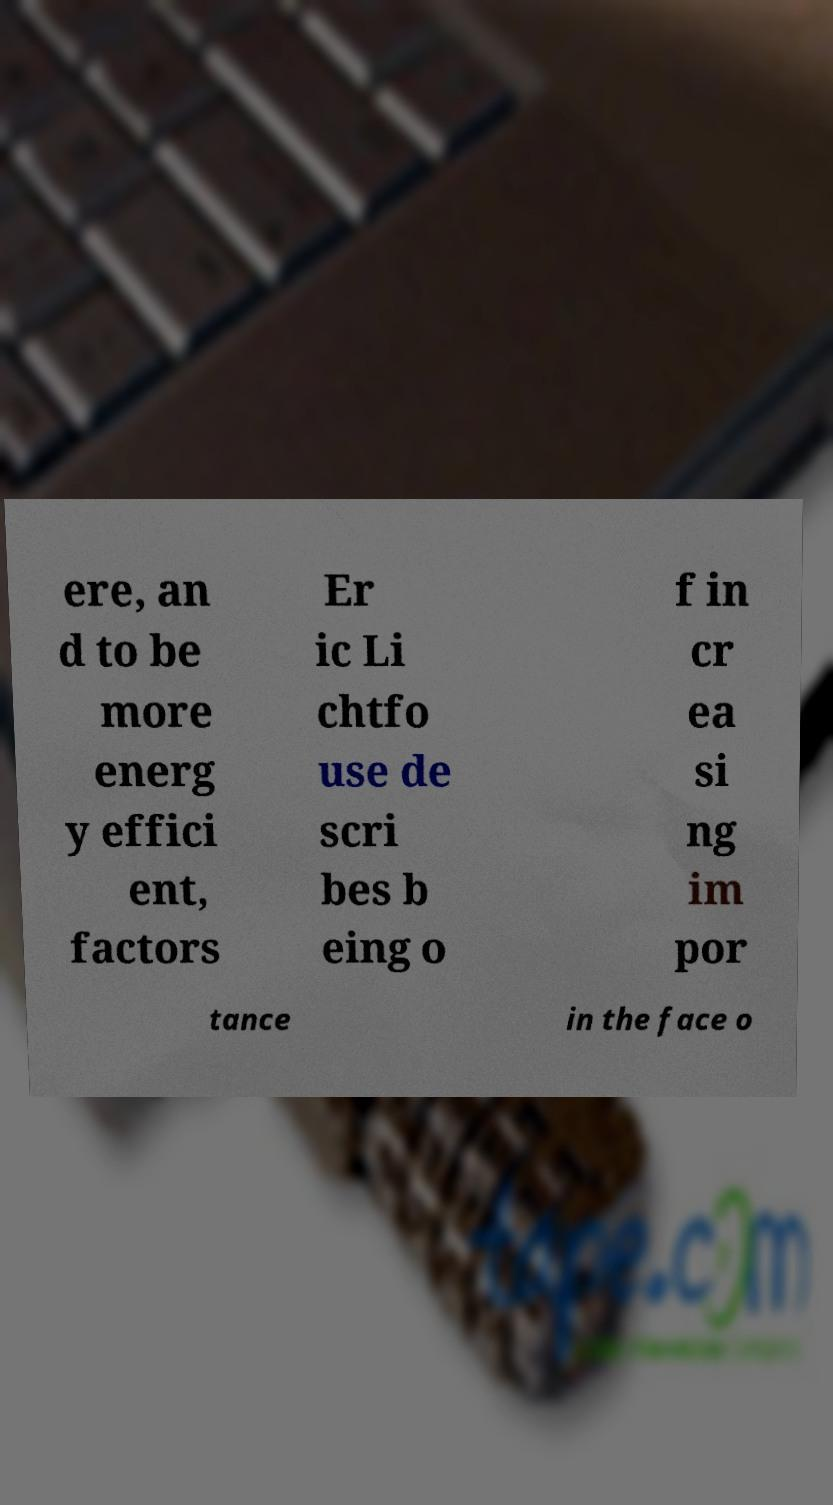There's text embedded in this image that I need extracted. Can you transcribe it verbatim? ere, an d to be more energ y effici ent, factors Er ic Li chtfo use de scri bes b eing o f in cr ea si ng im por tance in the face o 